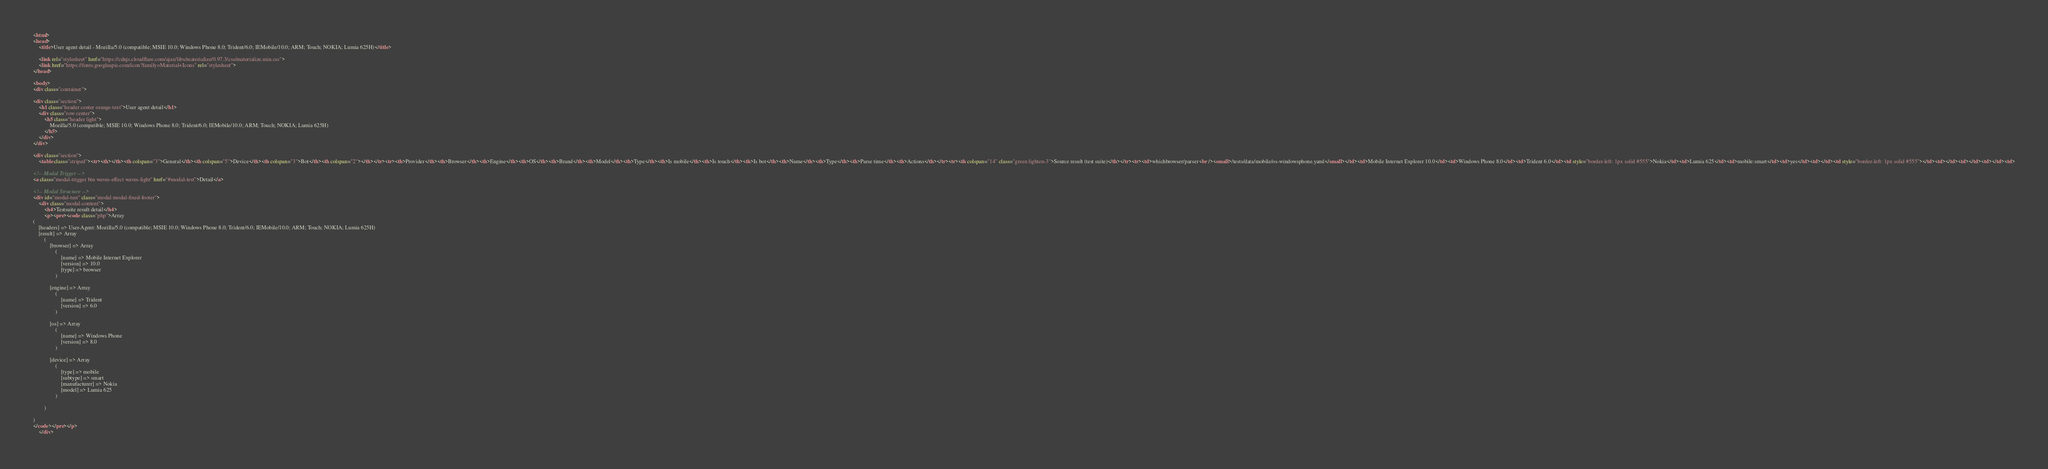Convert code to text. <code><loc_0><loc_0><loc_500><loc_500><_HTML_>
<html>
<head>
    <title>User agent detail - Mozilla/5.0 (compatible; MSIE 10.0; Windows Phone 8.0; Trident/6.0; IEMobile/10.0; ARM; Touch; NOKIA; Lumia 625H)</title>
        
    <link rel="stylesheet" href="https://cdnjs.cloudflare.com/ajax/libs/materialize/0.97.3/css/materialize.min.css">
    <link href="https://fonts.googleapis.com/icon?family=Material+Icons" rel="stylesheet">
</head>
        
<body>
<div class="container">
    
<div class="section">
	<h1 class="header center orange-text">User agent detail</h1>
	<div class="row center">
        <h5 class="header light">
            Mozilla/5.0 (compatible; MSIE 10.0; Windows Phone 8.0; Trident/6.0; IEMobile/10.0; ARM; Touch; NOKIA; Lumia 625H)
        </h5>
	</div>
</div>   

<div class="section">
    <table class="striped"><tr><th></th><th colspan="3">General</th><th colspan="5">Device</th><th colspan="3">Bot</th><th colspan="2"></th></tr><tr><th>Provider</th><th>Browser</th><th>Engine</th><th>OS</th><th>Brand</th><th>Model</th><th>Type</th><th>Is mobile</th><th>Is touch</th><th>Is bot</th><th>Name</th><th>Type</th><th>Parse time</th><th>Actions</th></tr><tr><th colspan="14" class="green lighten-3">Source result (test suite)</th></tr><tr><td>whichbrowser/parser<br /><small>/tests/data/mobile/os-windowsphone.yaml</small></td><td>Mobile Internet Explorer 10.0</td><td>Windows Phone 8.0</td><td>Trident 6.0</td><td style="border-left: 1px solid #555">Nokia</td><td>Lumia 625</td><td>mobile:smart</td><td>yes</td><td></td><td style="border-left: 1px solid #555"></td><td></td><td></td><td></td><td>
                
<!-- Modal Trigger -->
<a class="modal-trigger btn waves-effect waves-light" href="#modal-test">Detail</a>

<!-- Modal Structure -->
<div id="modal-test" class="modal modal-fixed-footer">
    <div class="modal-content">
        <h4>Testsuite result detail</h4>
        <p><pre><code class="php">Array
(
    [headers] => User-Agent: Mozilla/5.0 (compatible; MSIE 10.0; Windows Phone 8.0; Trident/6.0; IEMobile/10.0; ARM; Touch; NOKIA; Lumia 625H)
    [result] => Array
        (
            [browser] => Array
                (
                    [name] => Mobile Internet Explorer
                    [version] => 10.0
                    [type] => browser
                )

            [engine] => Array
                (
                    [name] => Trident
                    [version] => 6.0
                )

            [os] => Array
                (
                    [name] => Windows Phone
                    [version] => 8.0
                )

            [device] => Array
                (
                    [type] => mobile
                    [subtype] => smart
                    [manufacturer] => Nokia
                    [model] => Lumia 625
                )

        )

)
</code></pre></p>
    </div></code> 